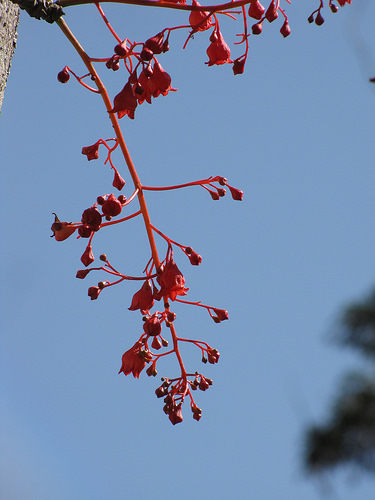<image>
Is the fruit on the sky? No. The fruit is not positioned on the sky. They may be near each other, but the fruit is not supported by or resting on top of the sky. 